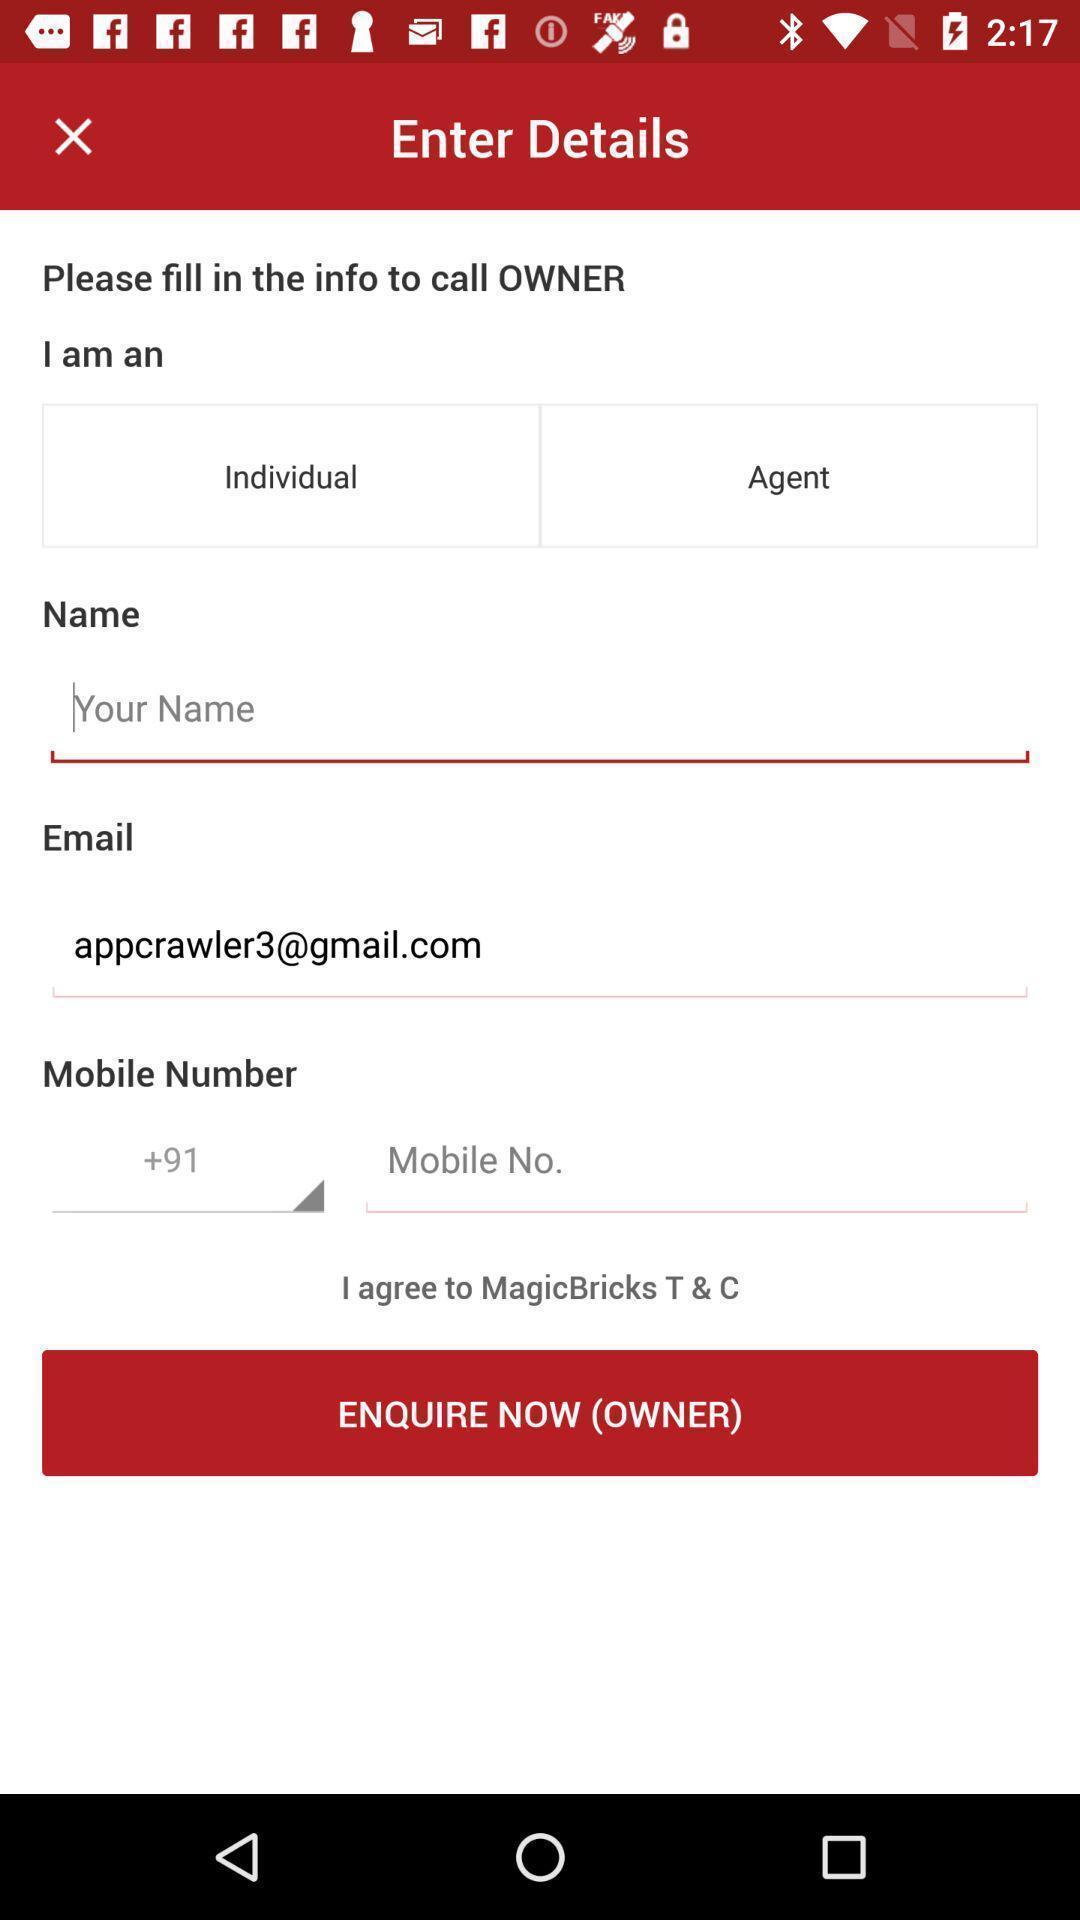Describe the visual elements of this screenshot. Page with different fields for personal info. 